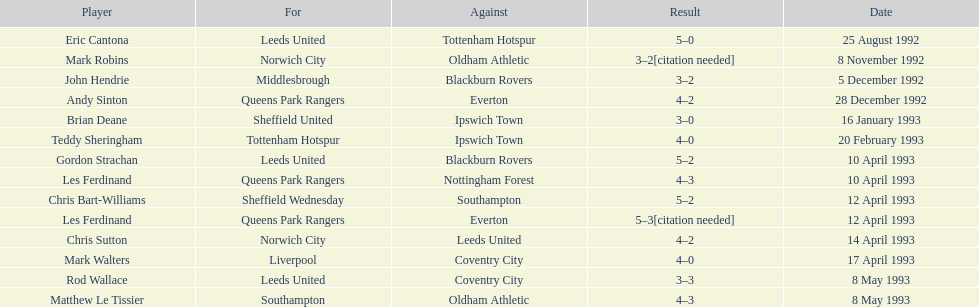I'm looking to parse the entire table for insights. Could you assist me with that? {'header': ['Player', 'For', 'Against', 'Result', 'Date'], 'rows': [['Eric Cantona', 'Leeds United', 'Tottenham Hotspur', '5–0', '25 August 1992'], ['Mark Robins', 'Norwich City', 'Oldham Athletic', '3–2[citation needed]', '8 November 1992'], ['John Hendrie', 'Middlesbrough', 'Blackburn Rovers', '3–2', '5 December 1992'], ['Andy Sinton', 'Queens Park Rangers', 'Everton', '4–2', '28 December 1992'], ['Brian Deane', 'Sheffield United', 'Ipswich Town', '3–0', '16 January 1993'], ['Teddy Sheringham', 'Tottenham Hotspur', 'Ipswich Town', '4–0', '20 February 1993'], ['Gordon Strachan', 'Leeds United', 'Blackburn Rovers', '5–2', '10 April 1993'], ['Les Ferdinand', 'Queens Park Rangers', 'Nottingham Forest', '4–3', '10 April 1993'], ['Chris Bart-Williams', 'Sheffield Wednesday', 'Southampton', '5–2', '12 April 1993'], ['Les Ferdinand', 'Queens Park Rangers', 'Everton', '5–3[citation needed]', '12 April 1993'], ['Chris Sutton', 'Norwich City', 'Leeds United', '4–2', '14 April 1993'], ['Mark Walters', 'Liverpool', 'Coventry City', '4–0', '17 April 1993'], ['Rod Wallace', 'Leeds United', 'Coventry City', '3–3', '8 May 1993'], ['Matthew Le Tissier', 'Southampton', 'Oldham Athletic', '4–3', '8 May 1993']]} Which squad did liverpool compete against? Coventry City. 